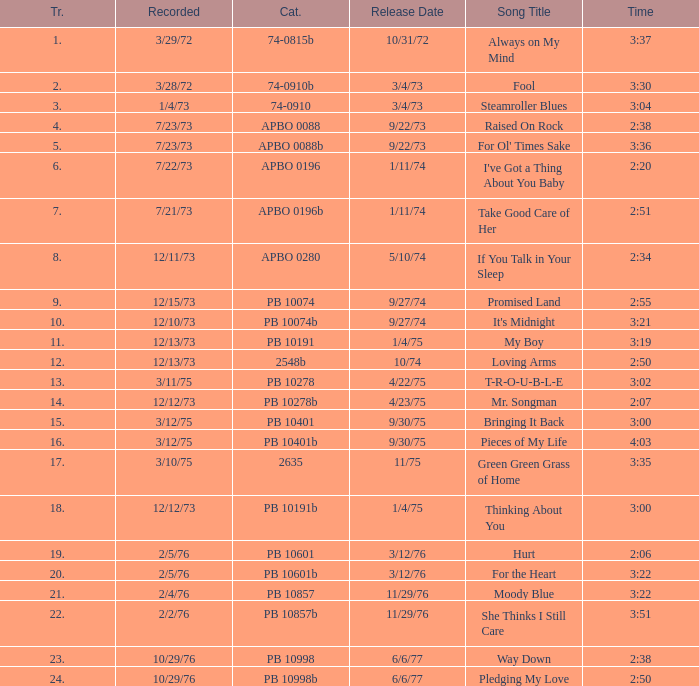Tell me the release date record on 10/29/76 and a time on 2:50 6/6/77. 